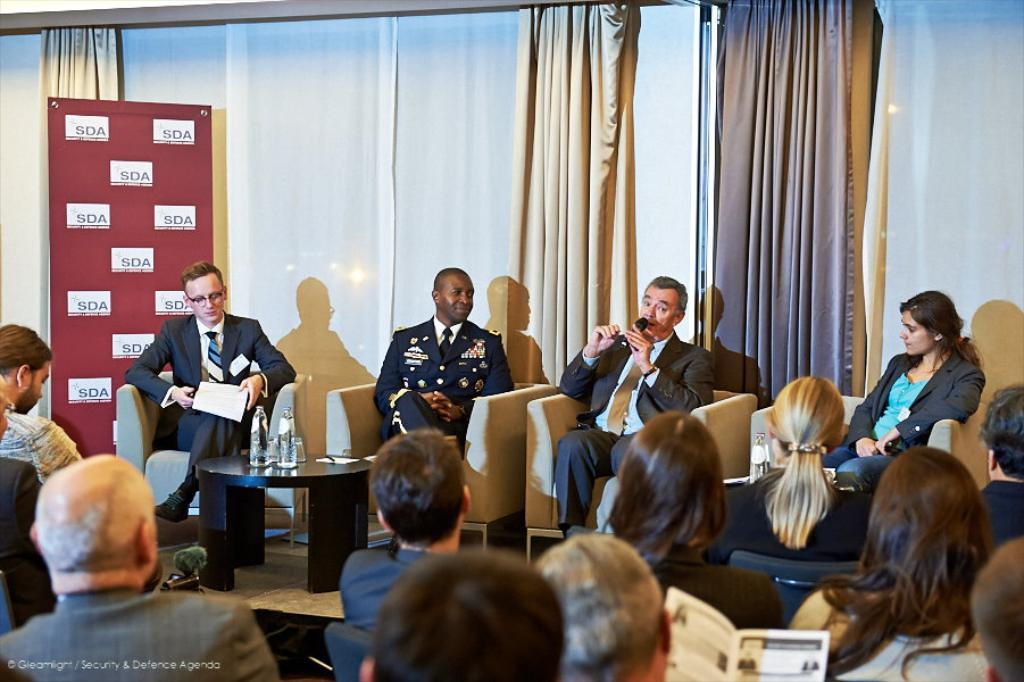How many people are in the image? There are four persons in the image. What are the persons doing in the image? The persons are sitting on a sofa. What is visible in the background of the image? There is a wall in the background of the image. What type of window treatment is present in the image? There are curtains associated with the wall in the background of the image. What type of boat can be seen in the image? There is no boat present in the image. What type of father can be seen in the image? There is no father present in the image. 